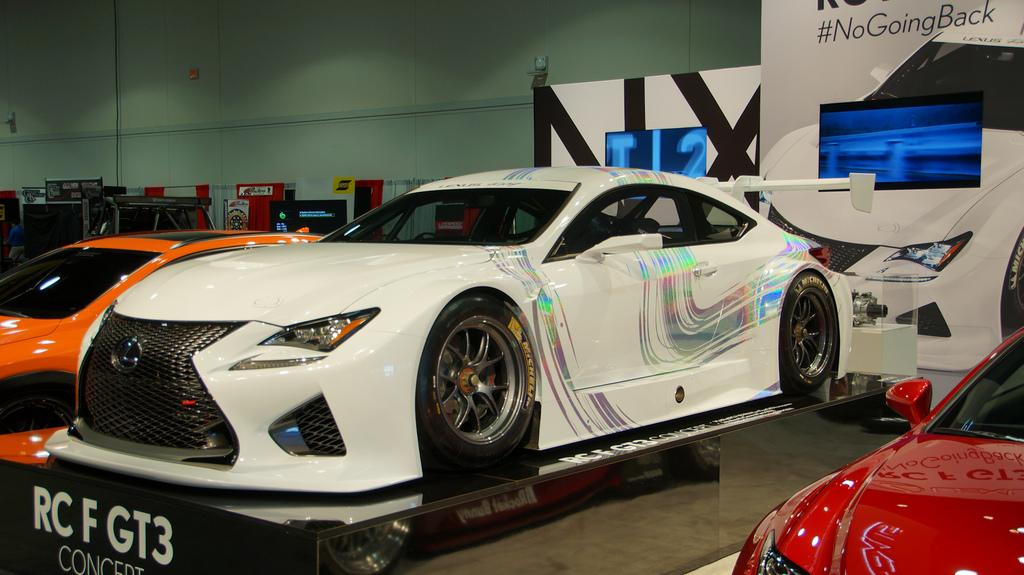What color is the car on the left side of the image? There is an orange car on the left side of the image. What color is the other car in the image? There is a white car in the image. Where is the glue being used in the image? There is no glue present in the image. What type of plantation can be seen in the image? There is no plantation present in the image. 